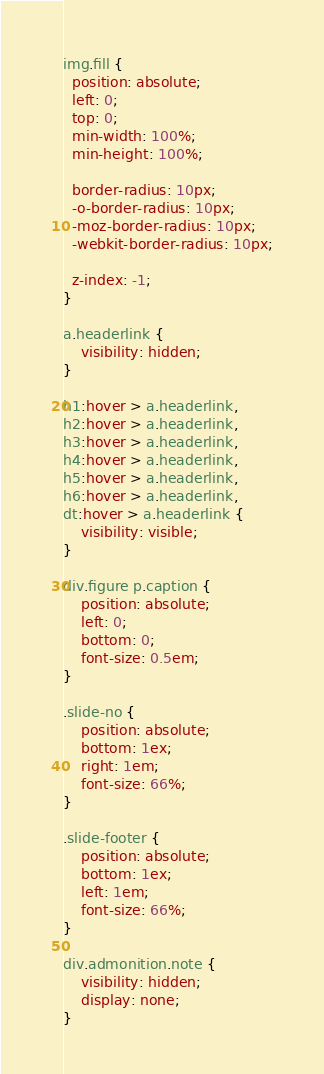<code> <loc_0><loc_0><loc_500><loc_500><_CSS_>img.fill {
  position: absolute;
  left: 0;
  top: 0;
  min-width: 100%;
  min-height: 100%;

  border-radius: 10px;
  -o-border-radius: 10px;
  -moz-border-radius: 10px;
  -webkit-border-radius: 10px;

  z-index: -1;
}

a.headerlink {
    visibility: hidden;
}

h1:hover > a.headerlink,
h2:hover > a.headerlink,
h3:hover > a.headerlink,
h4:hover > a.headerlink,
h5:hover > a.headerlink,
h6:hover > a.headerlink,
dt:hover > a.headerlink {
    visibility: visible;
}

div.figure p.caption {
    position: absolute;
    left: 0;
    bottom: 0;
    font-size: 0.5em;
}

.slide-no {
    position: absolute;
    bottom: 1ex;
    right: 1em;
    font-size: 66%;
}

.slide-footer {
    position: absolute;
    bottom: 1ex;
    left: 1em;
    font-size: 66%;
}

div.admonition.note {
    visibility: hidden;
    display: none;
}
</code> 